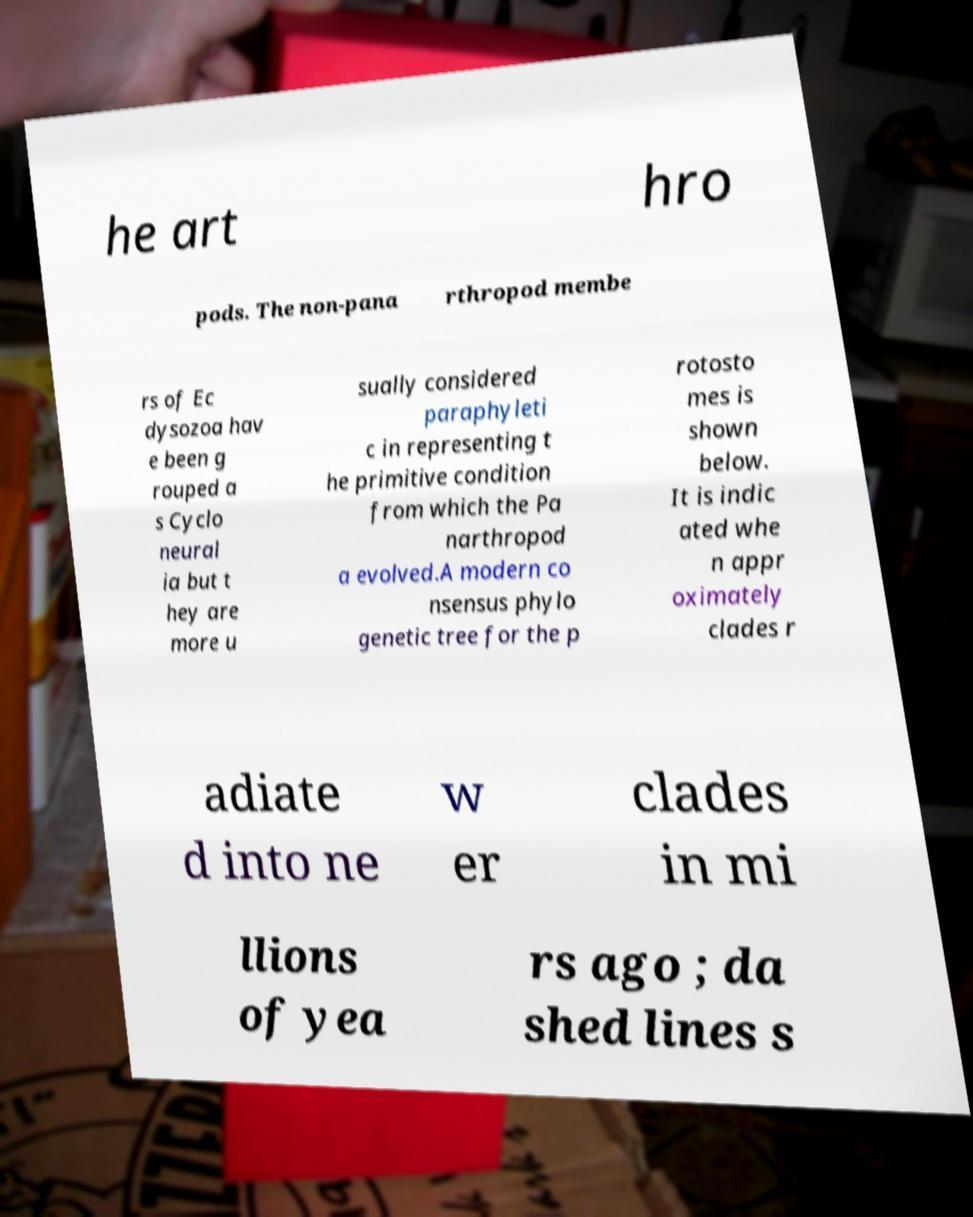Could you extract and type out the text from this image? he art hro pods. The non-pana rthropod membe rs of Ec dysozoa hav e been g rouped a s Cyclo neural ia but t hey are more u sually considered paraphyleti c in representing t he primitive condition from which the Pa narthropod a evolved.A modern co nsensus phylo genetic tree for the p rotosto mes is shown below. It is indic ated whe n appr oximately clades r adiate d into ne w er clades in mi llions of yea rs ago ; da shed lines s 